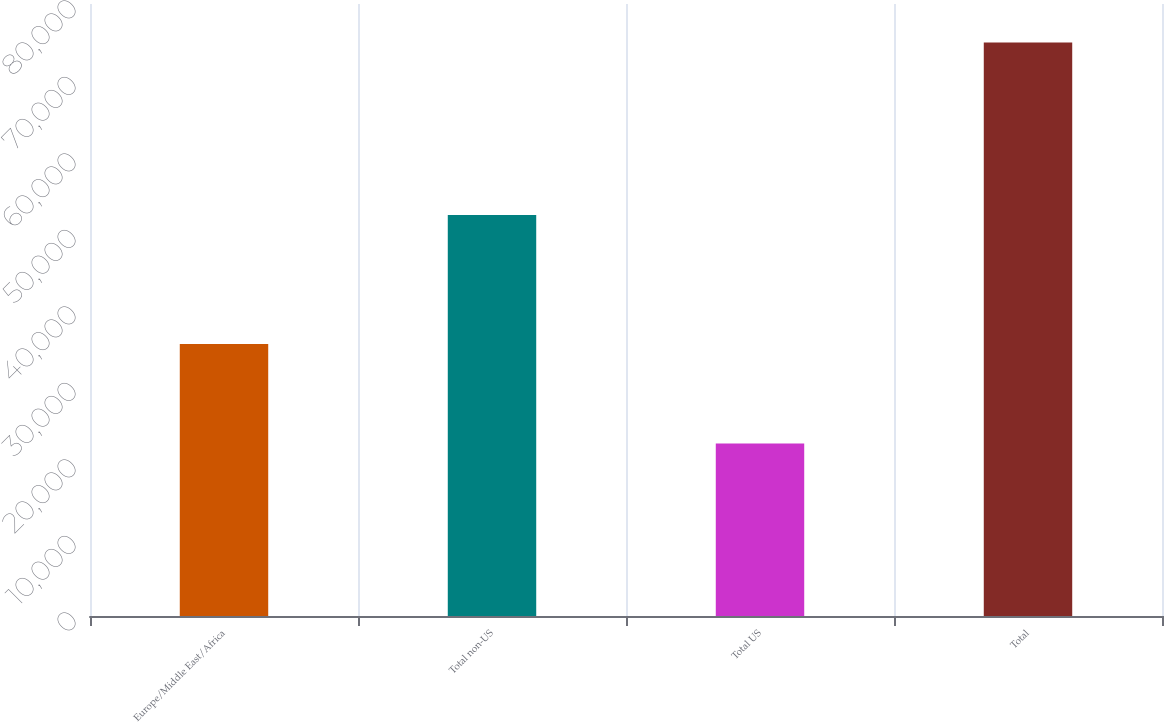Convert chart. <chart><loc_0><loc_0><loc_500><loc_500><bar_chart><fcel>Europe/Middle East/Africa<fcel>Total non-US<fcel>Total US<fcel>Total<nl><fcel>35561<fcel>52425<fcel>22558<fcel>74983<nl></chart> 